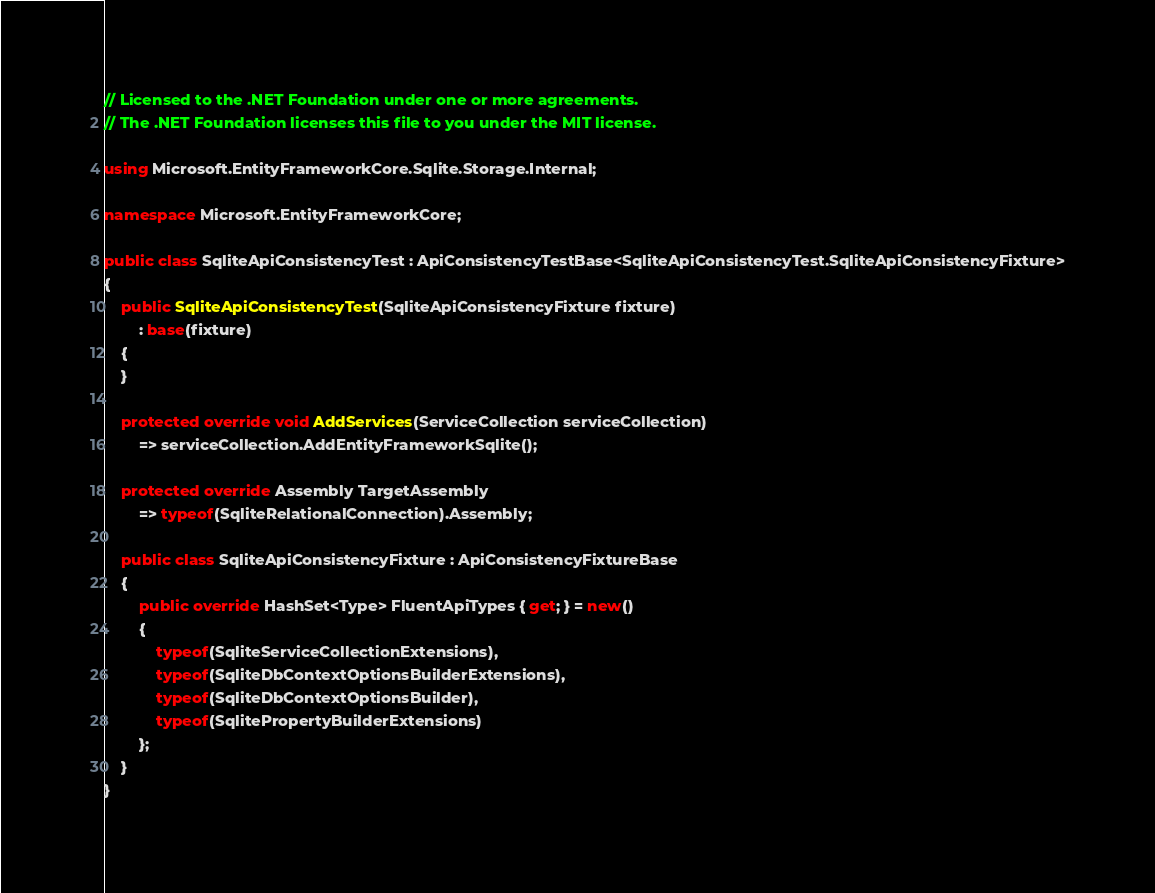<code> <loc_0><loc_0><loc_500><loc_500><_C#_>// Licensed to the .NET Foundation under one or more agreements.
// The .NET Foundation licenses this file to you under the MIT license.

using Microsoft.EntityFrameworkCore.Sqlite.Storage.Internal;

namespace Microsoft.EntityFrameworkCore;

public class SqliteApiConsistencyTest : ApiConsistencyTestBase<SqliteApiConsistencyTest.SqliteApiConsistencyFixture>
{
    public SqliteApiConsistencyTest(SqliteApiConsistencyFixture fixture)
        : base(fixture)
    {
    }

    protected override void AddServices(ServiceCollection serviceCollection)
        => serviceCollection.AddEntityFrameworkSqlite();

    protected override Assembly TargetAssembly
        => typeof(SqliteRelationalConnection).Assembly;

    public class SqliteApiConsistencyFixture : ApiConsistencyFixtureBase
    {
        public override HashSet<Type> FluentApiTypes { get; } = new()
        {
            typeof(SqliteServiceCollectionExtensions),
            typeof(SqliteDbContextOptionsBuilderExtensions),
            typeof(SqliteDbContextOptionsBuilder),
            typeof(SqlitePropertyBuilderExtensions)
        };
    }
}
</code> 